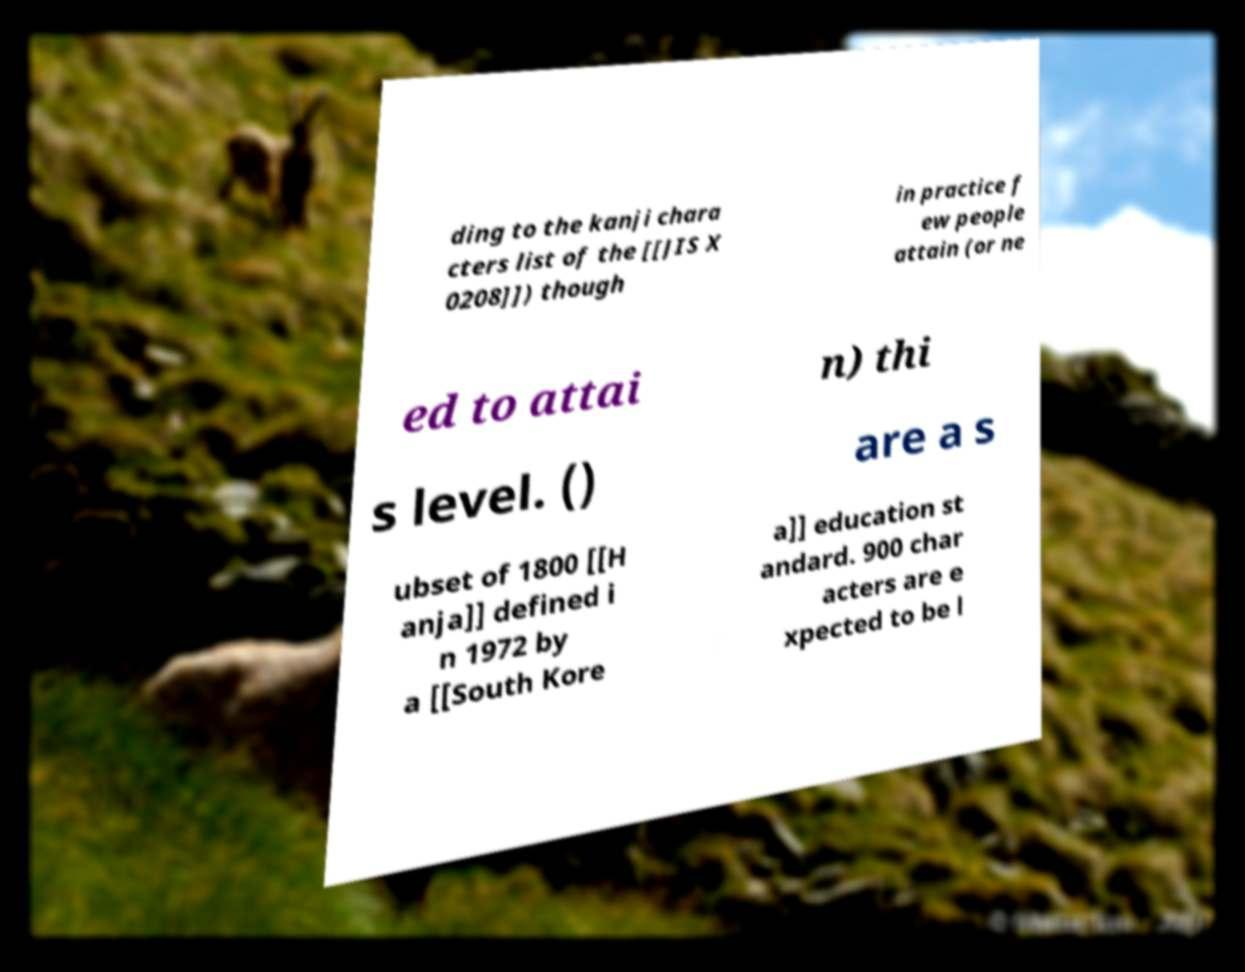Please read and relay the text visible in this image. What does it say? ding to the kanji chara cters list of the [[JIS X 0208]]) though in practice f ew people attain (or ne ed to attai n) thi s level. () are a s ubset of 1800 [[H anja]] defined i n 1972 by a [[South Kore a]] education st andard. 900 char acters are e xpected to be l 